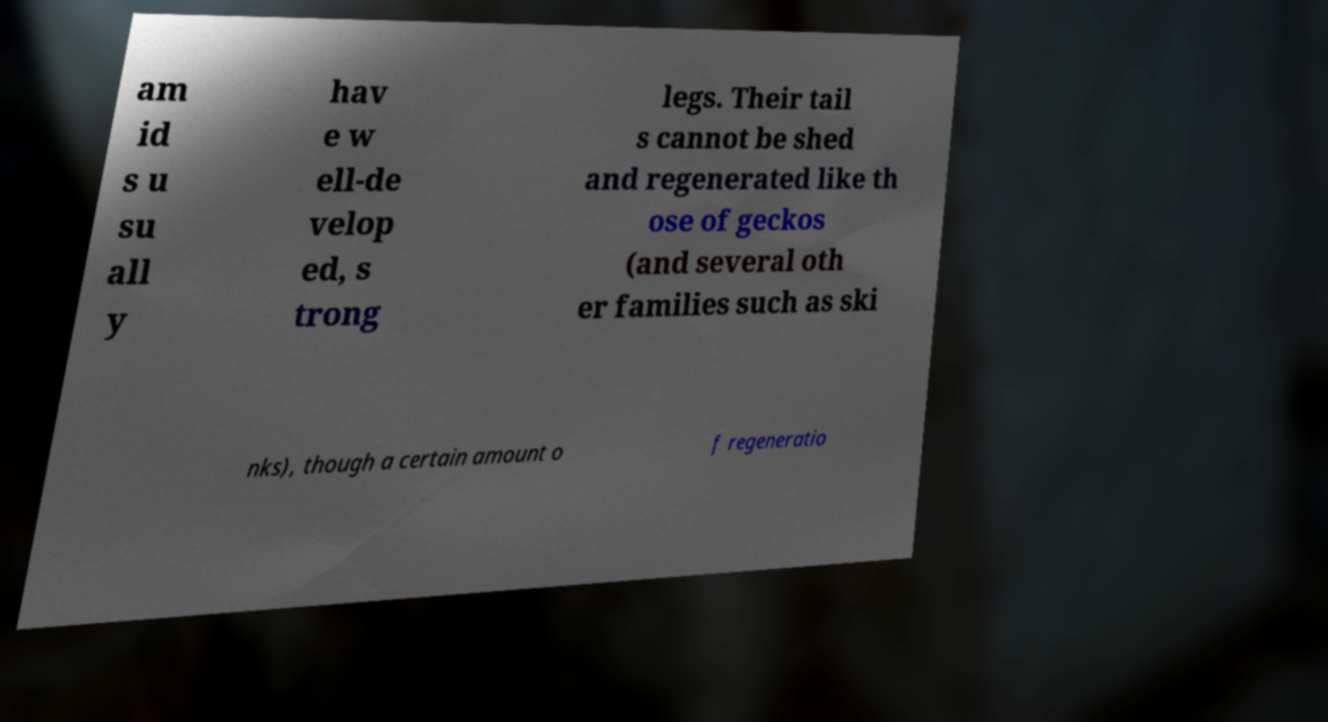Can you accurately transcribe the text from the provided image for me? am id s u su all y hav e w ell-de velop ed, s trong legs. Their tail s cannot be shed and regenerated like th ose of geckos (and several oth er families such as ski nks), though a certain amount o f regeneratio 